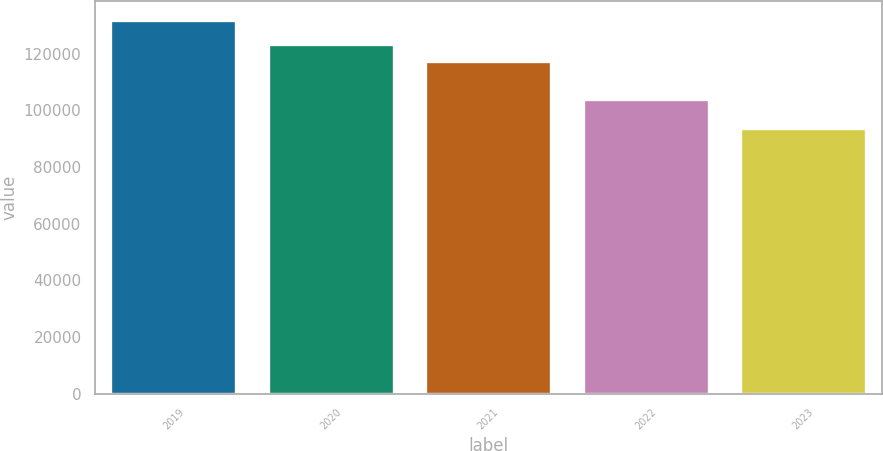Convert chart. <chart><loc_0><loc_0><loc_500><loc_500><bar_chart><fcel>2019<fcel>2020<fcel>2021<fcel>2022<fcel>2023<nl><fcel>131936<fcel>123425<fcel>117381<fcel>103917<fcel>93854<nl></chart> 